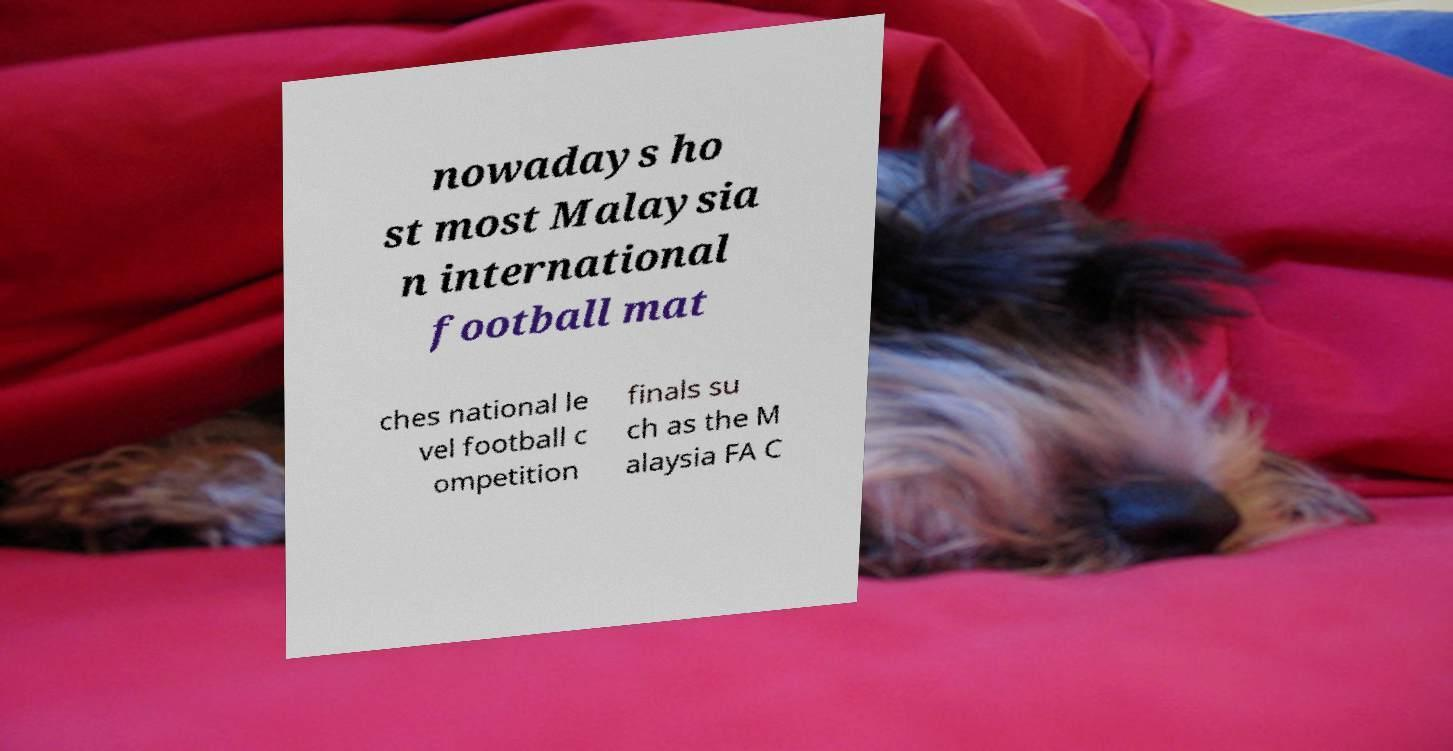Can you accurately transcribe the text from the provided image for me? nowadays ho st most Malaysia n international football mat ches national le vel football c ompetition finals su ch as the M alaysia FA C 